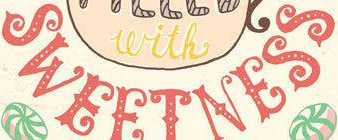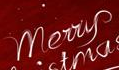What text appears in these images from left to right, separated by a semicolon? SWEETNESS; Merry 